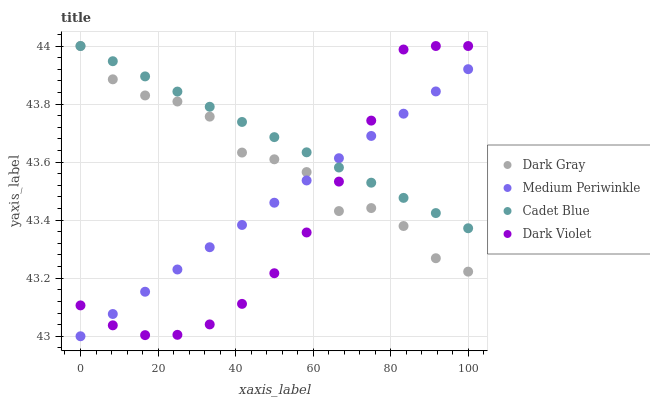Does Dark Violet have the minimum area under the curve?
Answer yes or no. Yes. Does Cadet Blue have the maximum area under the curve?
Answer yes or no. Yes. Does Medium Periwinkle have the minimum area under the curve?
Answer yes or no. No. Does Medium Periwinkle have the maximum area under the curve?
Answer yes or no. No. Is Cadet Blue the smoothest?
Answer yes or no. Yes. Is Dark Gray the roughest?
Answer yes or no. Yes. Is Medium Periwinkle the smoothest?
Answer yes or no. No. Is Medium Periwinkle the roughest?
Answer yes or no. No. Does Medium Periwinkle have the lowest value?
Answer yes or no. Yes. Does Cadet Blue have the lowest value?
Answer yes or no. No. Does Dark Violet have the highest value?
Answer yes or no. Yes. Does Medium Periwinkle have the highest value?
Answer yes or no. No. Does Dark Gray intersect Cadet Blue?
Answer yes or no. Yes. Is Dark Gray less than Cadet Blue?
Answer yes or no. No. Is Dark Gray greater than Cadet Blue?
Answer yes or no. No. 